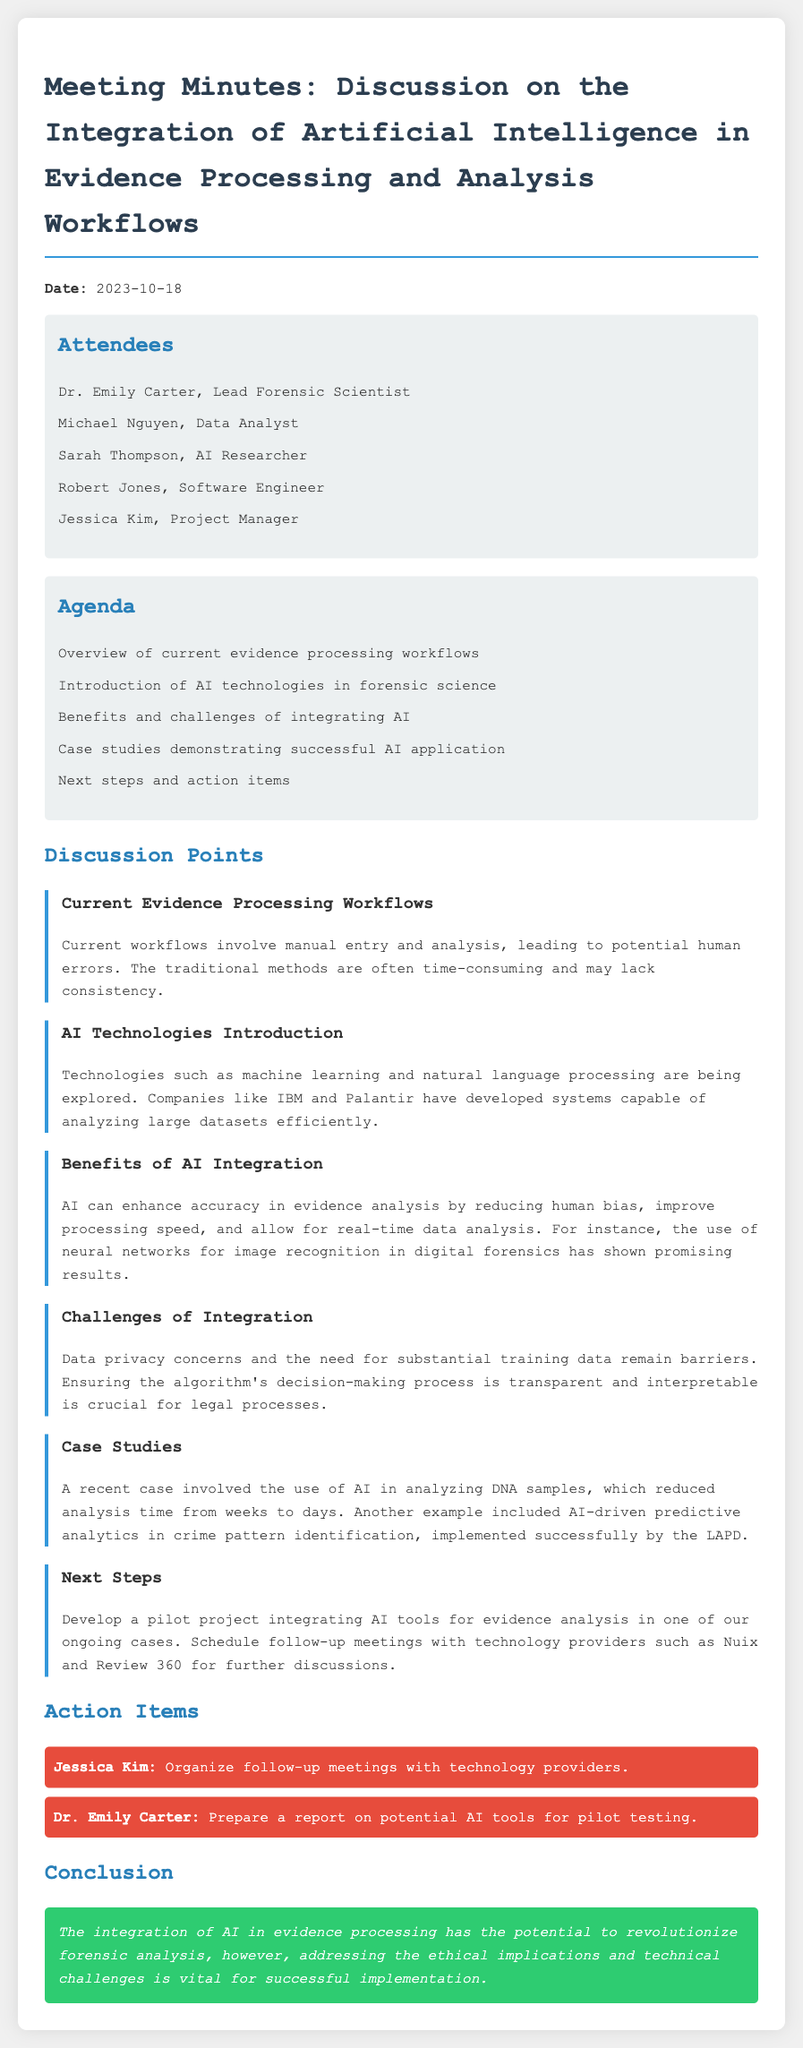What is the date of the meeting? The date of the meeting is mentioned at the top of the document.
Answer: 2023-10-18 Who is the lead forensic scientist? This information can be found in the list of attendees.
Answer: Dr. Emily Carter What technologies are being explored for AI in forensic science? The discussion on AI technologies confirms what is being explored.
Answer: Machine learning and natural language processing What is a benefit of AI integration mentioned? Benefits discussed in the meeting highlight advantages of AI.
Answer: Enhance accuracy What challenge of AI integration is identified? The challenges are outlined in the respective discussion point.
Answer: Data privacy concerns How much time did AI reduce DNA analysis from? This detail is provided in the case studies section.
Answer: Weeks to days What is an action item for Jessica Kim? Action items are listed towards the end of the minutes.
Answer: Organize follow-up meetings with technology providers What is stated in the conclusion about AI's potential? The conclusion summarizes the general viability of AI in forensic analysis.
Answer: Revolutionize forensic analysis Which company is referenced for AI-driven predictive analytics? The case studies section mentions a specific department that used this technology.
Answer: LAPD 